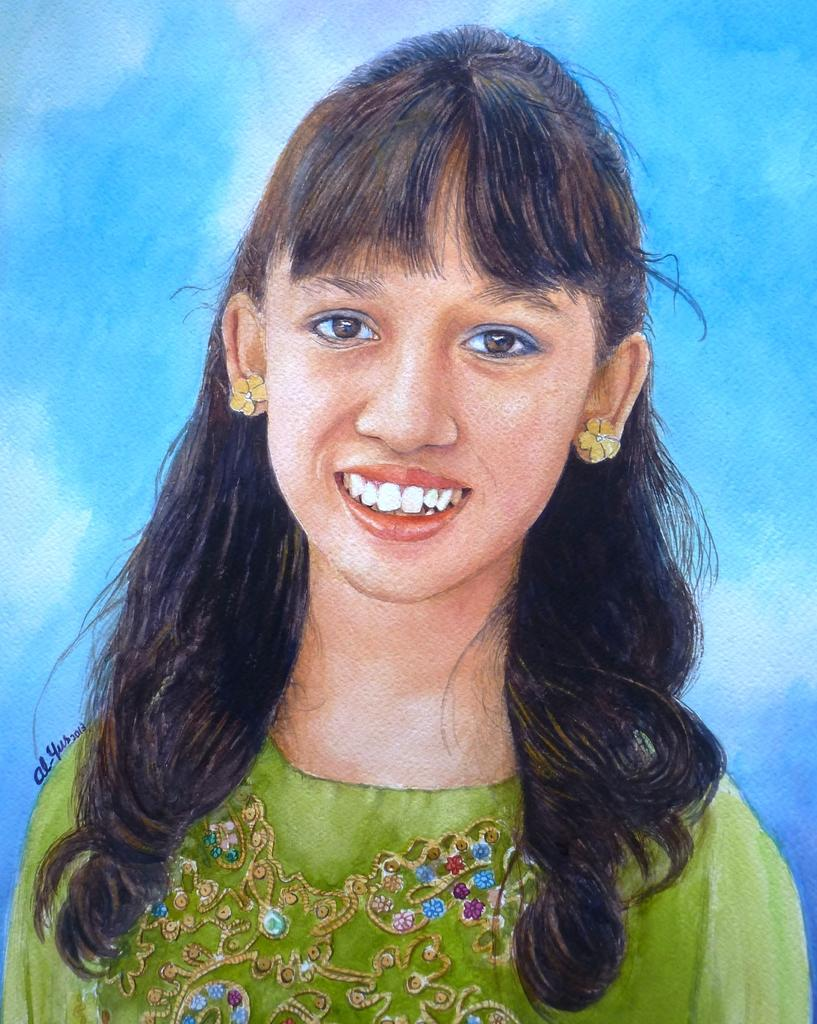What is the main subject of the image? The main subject of the image is a colorful sketch painting. What does the painting depict? The painting depicts one girl. Where is the butter placed in the image? There is no butter present in the image. What type of bedroom is shown in the image? The image does not depict a bedroom; it features a colorful sketch painting of a girl. 